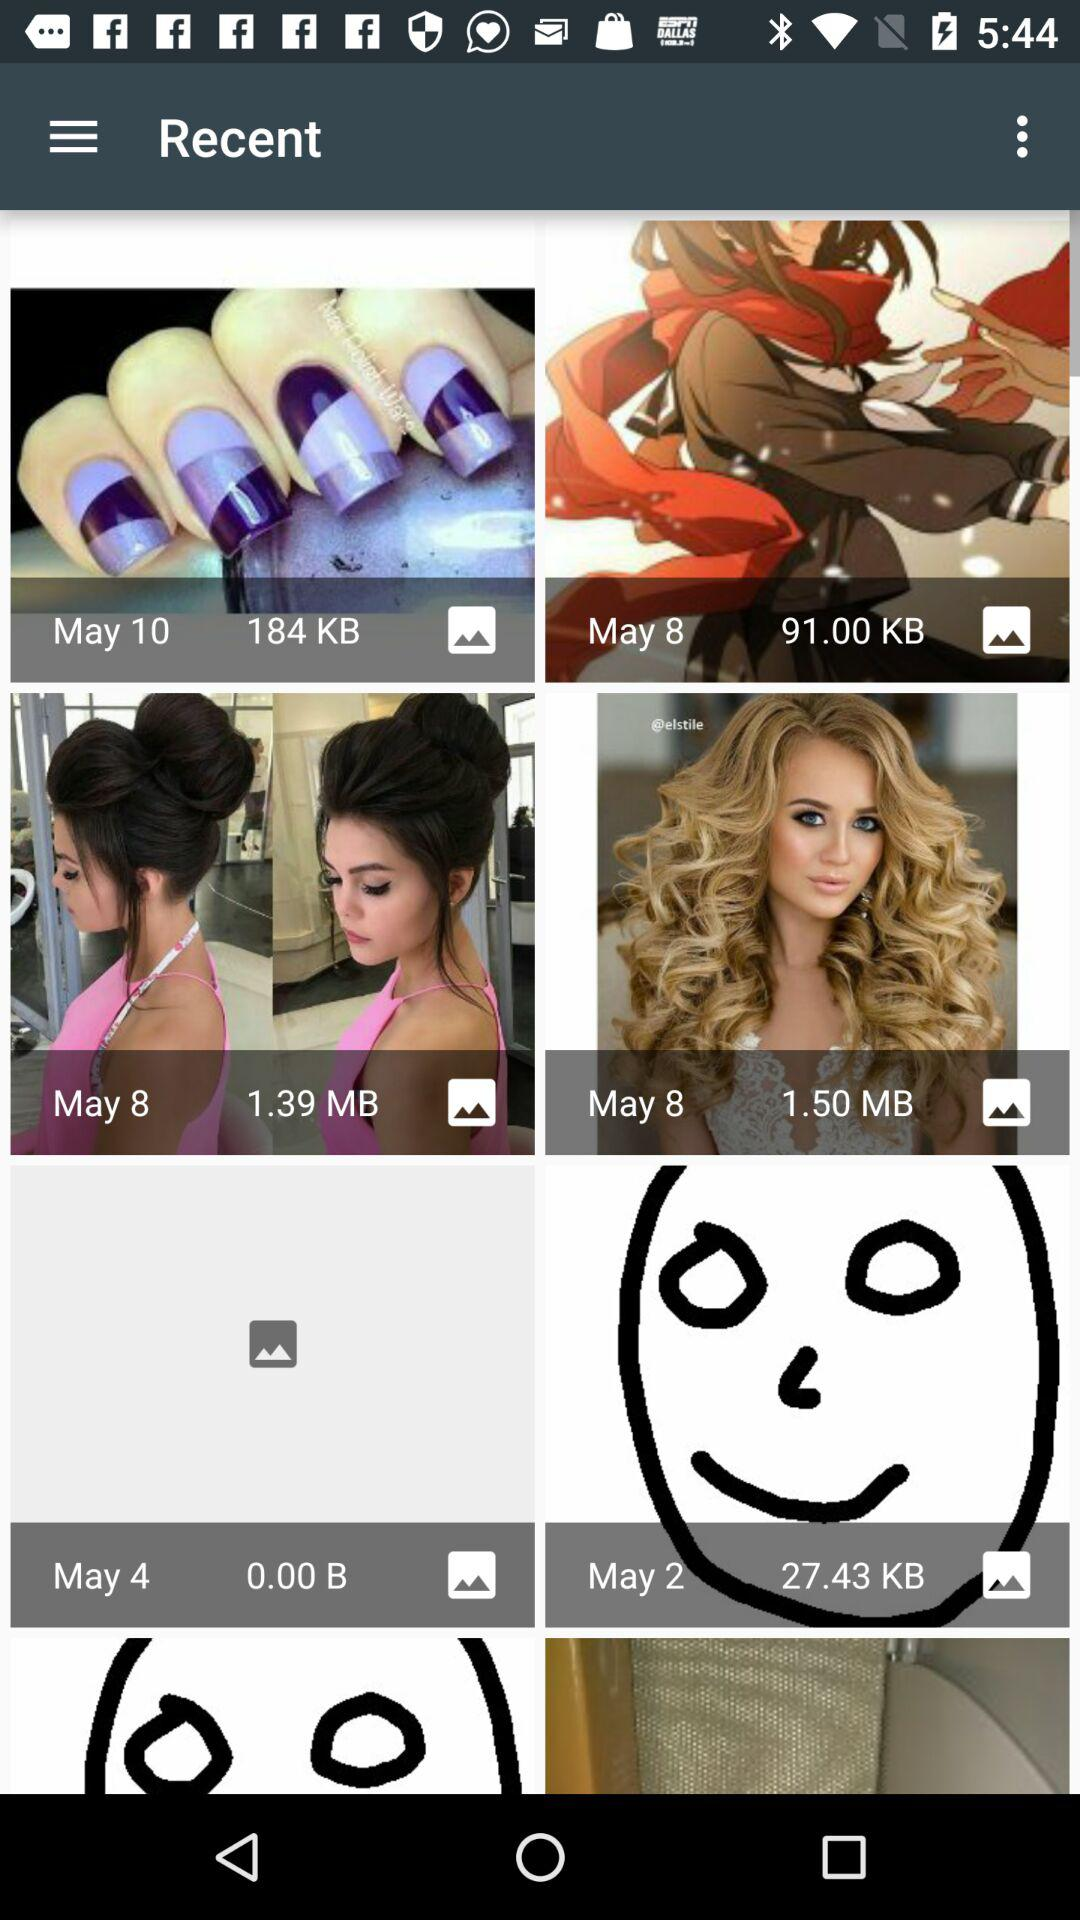Who posted the images?
When the provided information is insufficient, respond with <no answer>. <no answer> 